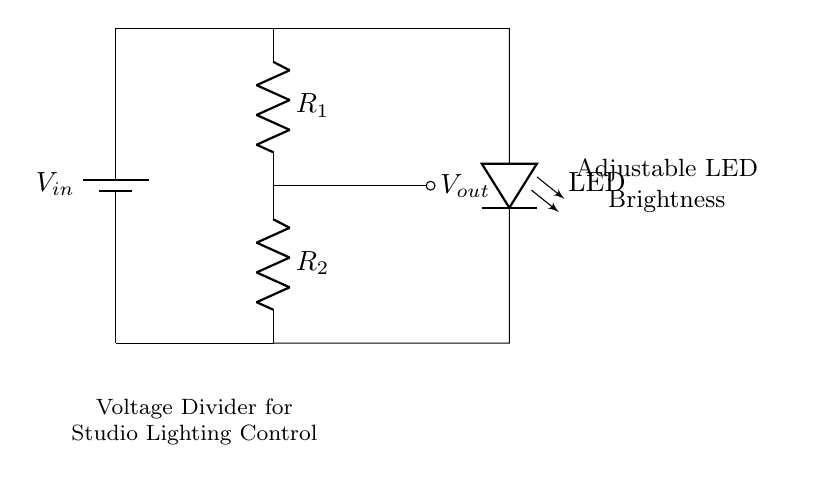What is the input voltage in the circuit? The input voltage is denoted as V_in, which is the voltage supplied by the battery connected at the top of the circuit diagram.
Answer: V_in What are the resistance values in the voltage divider? The circuit includes two resistors labeled R_1 and R_2, which form the voltage divider. The specific resistance values are not provided in the visual, but both components are indicated.
Answer: R_1 and R_2 What is the purpose of the LED in this circuit? The LED is used to provide illumination, and its brightness can be adjusted by changing the output voltage V_out derived from the voltage divider.
Answer: Adjustable brightness What is the output voltage denoted as in this circuit? The output voltage is denoted as V_out, which is taken from the middle point between the two resistors in the voltage divider and is connected to the LED for brightness control.
Answer: V_out How does adjusting R_1 or R_2 affect the LED? Adjusting either R_1 or R_2 changes the ratio of the resistances in the voltage divider, thereby altering the output voltage V_out, which directly influences the brightness of the LED; higher resistance generally results in lower brightness.
Answer: Changes brightness What type of circuit configuration is being used in this setup? This is a voltage divider circuit configuration specifically used to control the brightness of an LED based on the division of input voltage across two resistors.
Answer: Voltage divider 